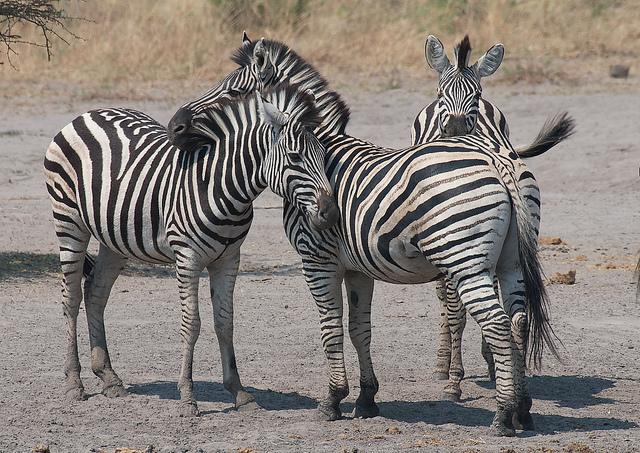Are the animals the same type?
Keep it brief. Yes. How many zebra are standing in the dirt?
Be succinct. 3. How many zebras have dirty hoofs?
Concise answer only. 3. What animal is this?
Short answer required. Zebra. How many zebras are in the picture?
Short answer required. 3. Are the zebras being hunted?
Short answer required. No. Are the animals running?
Be succinct. No. 